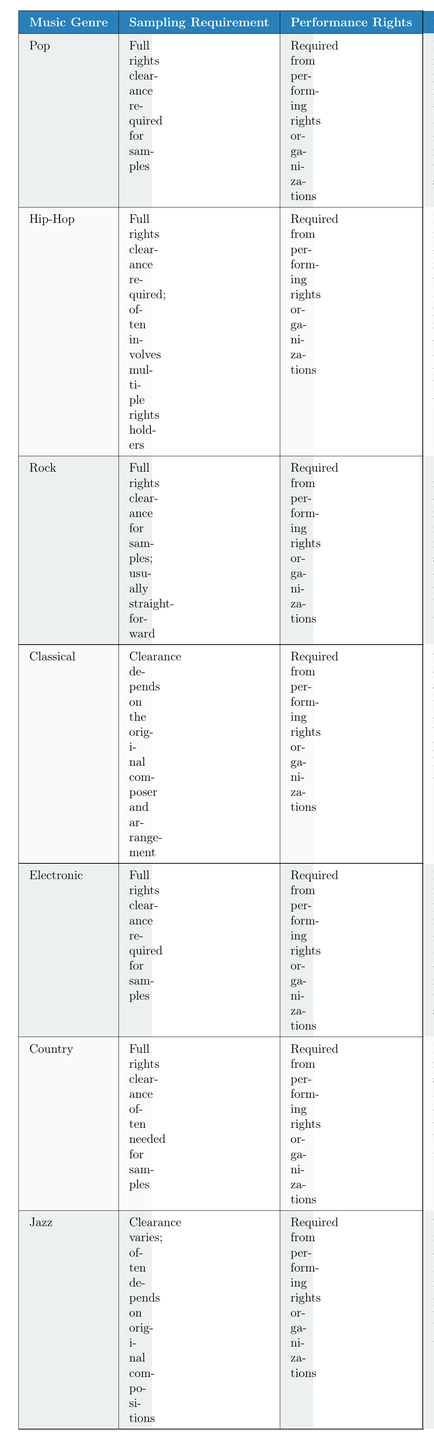What are the sampling requirements for Rock music? According to the table, the sampling requirement for Rock music is "Full rights clearance for samples; usually straightforward."
Answer: Full rights clearance for samples; usually straightforward Is mechanical licensing required for digital sales in Pop music? Yes, the table states that for Pop music, "Mechanical Licensing" is "Required for physical and digital sales."
Answer: Yes How many music genres require sync licensing for media uses? The table lists four genres that require sync licensing: Pop, Hip-Hop, Classical, and Electronic. Therefore, the total count is four.
Answer: 4 Does Jazz have a specific sampling requirement mentioned? The table indicates that for Jazz, "Clearance varies; often depends on original compositions," which suggests there is no singular requirement.
Answer: Yes Which genre requires performance rights from performing rights organizations? The table shows that all listed genres (Pop, Hip-Hop, Rock, Classical, Electronic, Country, and Jazz) require performance rights from performing rights organizations.
Answer: All genres What is the difference in sampling requirements between Electronic and Classical music? For Electronic music, the sampling requirement is "Full rights clearance required for samples," while for Classical music, it's "Clearance depends on the original composer and arrangement." Therefore, the key difference is that Electronic music has a straightforward requirement, whereas Classical's requirement depends on specific original works.
Answer: Electronic requires full rights clearance; Classical depends on original works Does Country music require sync licensing for advertisements? Yes, the table states that sync licensing is "Necessary for film, TV, and ads" in Country music.
Answer: Yes Which genre does not clearly specify sampling requirements and why? Jazz does not clearly specify sampling requirements because its clearance varies and often depends on the original compositions, rather than having a standardized requirement.
Answer: Jazz How do the mechanical licensing requirements for Hip-Hop and Rock differ? The table states that Hip-Hop requires "Mechanical Licensing" for "digital and physical distribution," while Rock states it is a "Standard requirement for music distribution." The difference highlights that Hip-Hop is specifically focused on both distribution formats, while Rock's statement is more general.
Answer: Hip-Hop is specific for both distribution formats; Rock is general 